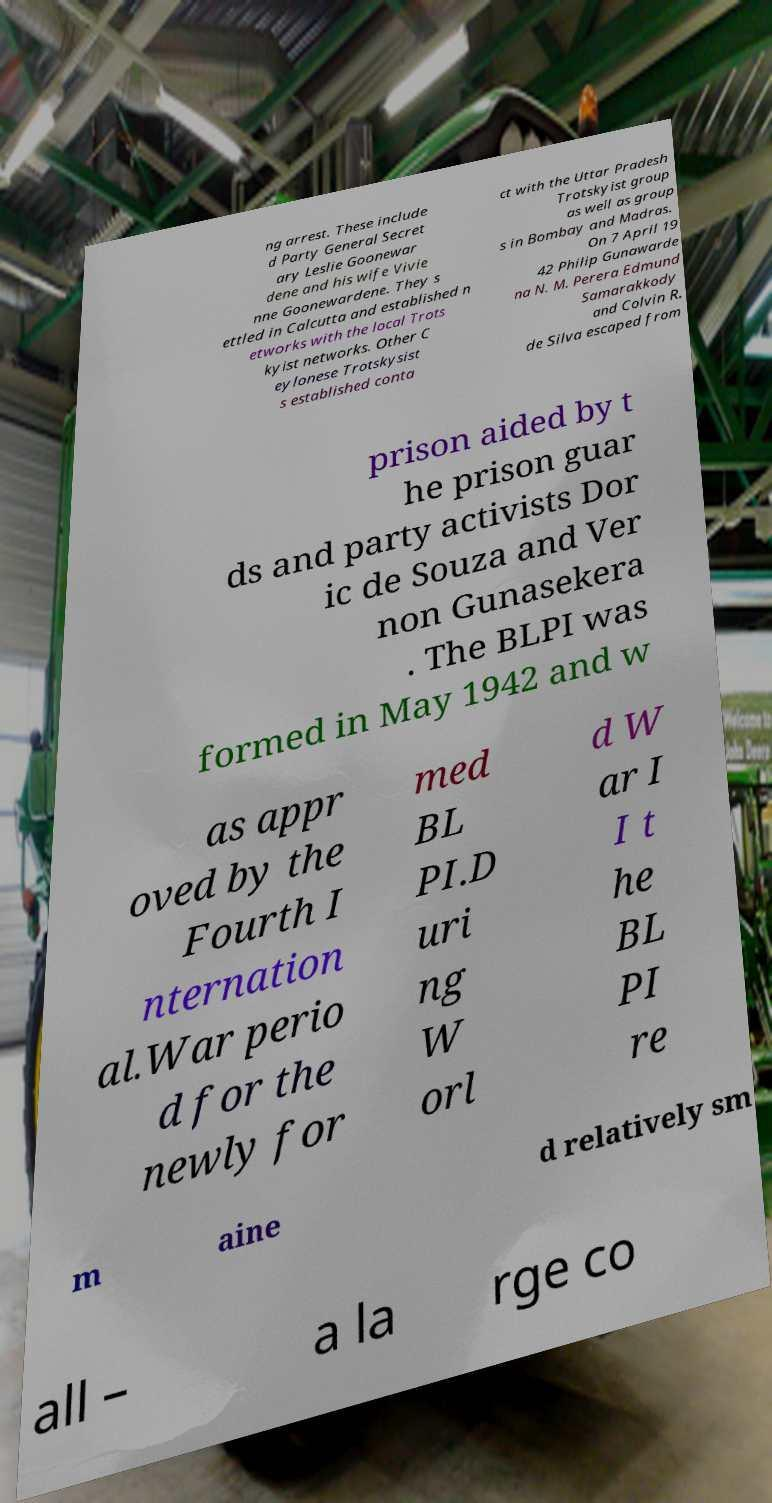There's text embedded in this image that I need extracted. Can you transcribe it verbatim? ng arrest. These include d Party General Secret ary Leslie Goonewar dene and his wife Vivie nne Goonewardene. They s ettled in Calcutta and established n etworks with the local Trots kyist networks. Other C eylonese Trotskysist s established conta ct with the Uttar Pradesh Trotskyist group as well as group s in Bombay and Madras. On 7 April 19 42 Philip Gunawarde na N. M. Perera Edmund Samarakkody and Colvin R. de Silva escaped from prison aided by t he prison guar ds and party activists Dor ic de Souza and Ver non Gunasekera . The BLPI was formed in May 1942 and w as appr oved by the Fourth I nternation al.War perio d for the newly for med BL PI.D uri ng W orl d W ar I I t he BL PI re m aine d relatively sm all – a la rge co 